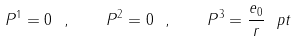<formula> <loc_0><loc_0><loc_500><loc_500>P ^ { 1 } = 0 \ , \quad P ^ { 2 } = 0 \ , \quad P ^ { 3 } = \frac { e _ { 0 } } { r } \ p t</formula> 